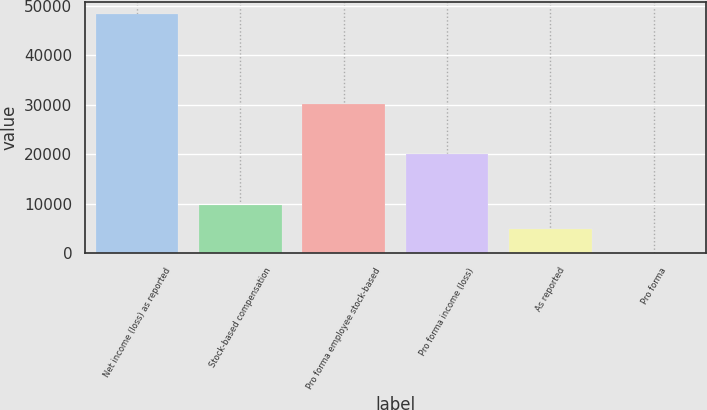<chart> <loc_0><loc_0><loc_500><loc_500><bar_chart><fcel>Net income (loss) as reported<fcel>Stock-based compensation<fcel>Pro forma employee stock-based<fcel>Pro forma income (loss)<fcel>As reported<fcel>Pro forma<nl><fcel>48423<fcel>9684.8<fcel>30116<fcel>20075<fcel>4842.52<fcel>0.24<nl></chart> 